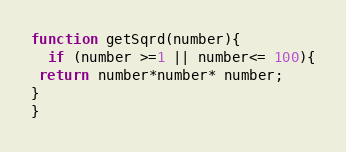Convert code to text. <code><loc_0><loc_0><loc_500><loc_500><_JavaScript_>function getSqrd(number){
  if (number >=1 || number<= 100){
 return number*number* number;  
}
}
</code> 